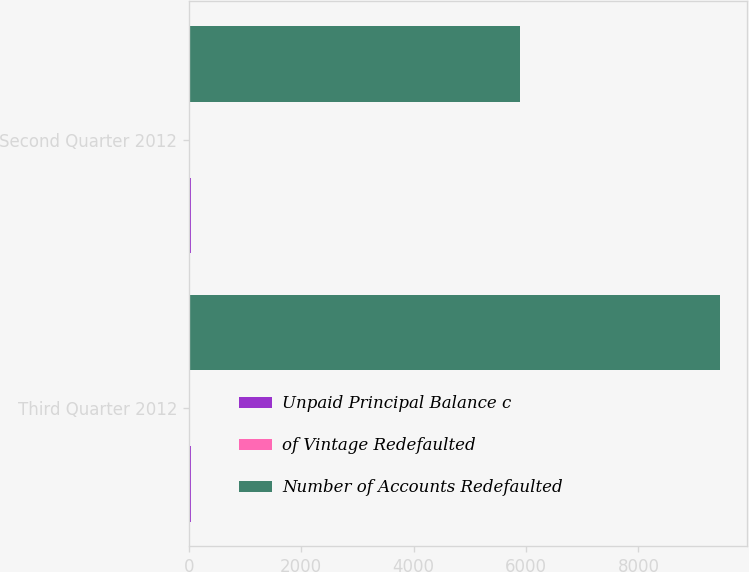Convert chart to OTSL. <chart><loc_0><loc_0><loc_500><loc_500><stacked_bar_chart><ecel><fcel>Third Quarter 2012<fcel>Second Quarter 2012<nl><fcel>Unpaid Principal Balance c<fcel>46<fcel>35<nl><fcel>of Vintage Redefaulted<fcel>2.9<fcel>2<nl><fcel>Number of Accounts Redefaulted<fcel>9452<fcel>5899<nl></chart> 